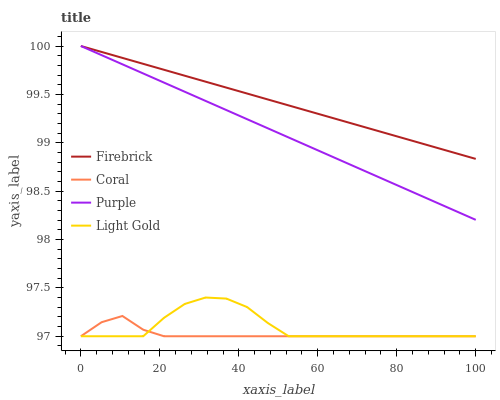Does Coral have the minimum area under the curve?
Answer yes or no. Yes. Does Firebrick have the maximum area under the curve?
Answer yes or no. Yes. Does Light Gold have the minimum area under the curve?
Answer yes or no. No. Does Light Gold have the maximum area under the curve?
Answer yes or no. No. Is Firebrick the smoothest?
Answer yes or no. Yes. Is Light Gold the roughest?
Answer yes or no. Yes. Is Light Gold the smoothest?
Answer yes or no. No. Is Firebrick the roughest?
Answer yes or no. No. Does Light Gold have the lowest value?
Answer yes or no. Yes. Does Firebrick have the lowest value?
Answer yes or no. No. Does Firebrick have the highest value?
Answer yes or no. Yes. Does Light Gold have the highest value?
Answer yes or no. No. Is Light Gold less than Purple?
Answer yes or no. Yes. Is Firebrick greater than Coral?
Answer yes or no. Yes. Does Coral intersect Light Gold?
Answer yes or no. Yes. Is Coral less than Light Gold?
Answer yes or no. No. Is Coral greater than Light Gold?
Answer yes or no. No. Does Light Gold intersect Purple?
Answer yes or no. No. 